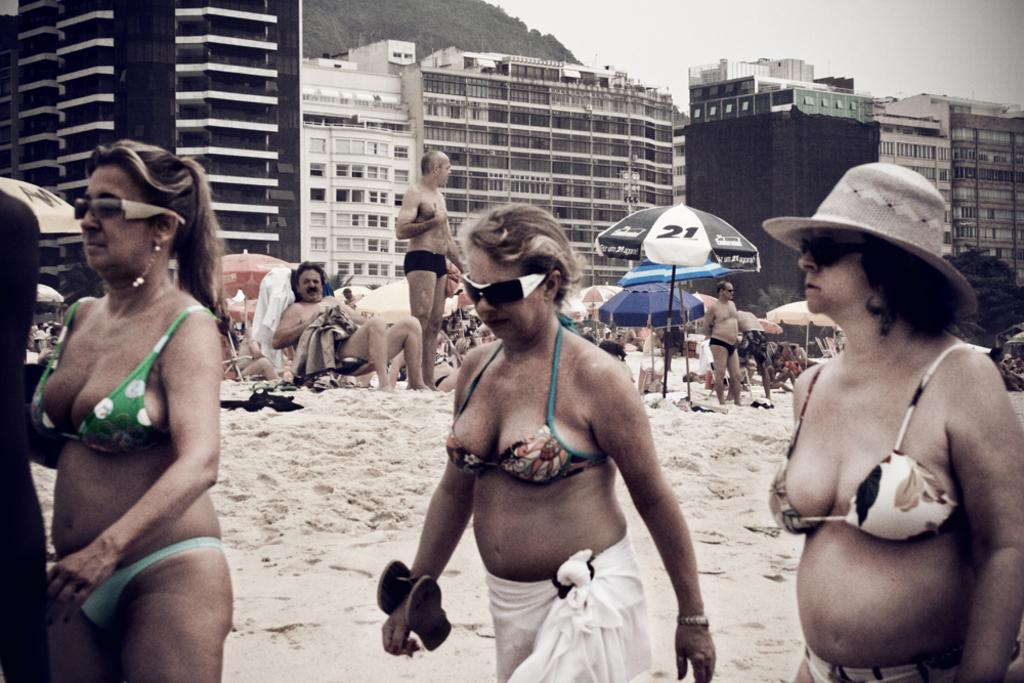How many people are present in the image? There are three people in the image. What can be seen in the background of the image? There are umbrellas, people, and buildings in the background of the image. What type of reaction can be seen from the desk in the image? There is no desk present in the image, so it is not possible to determine any reaction from it. 